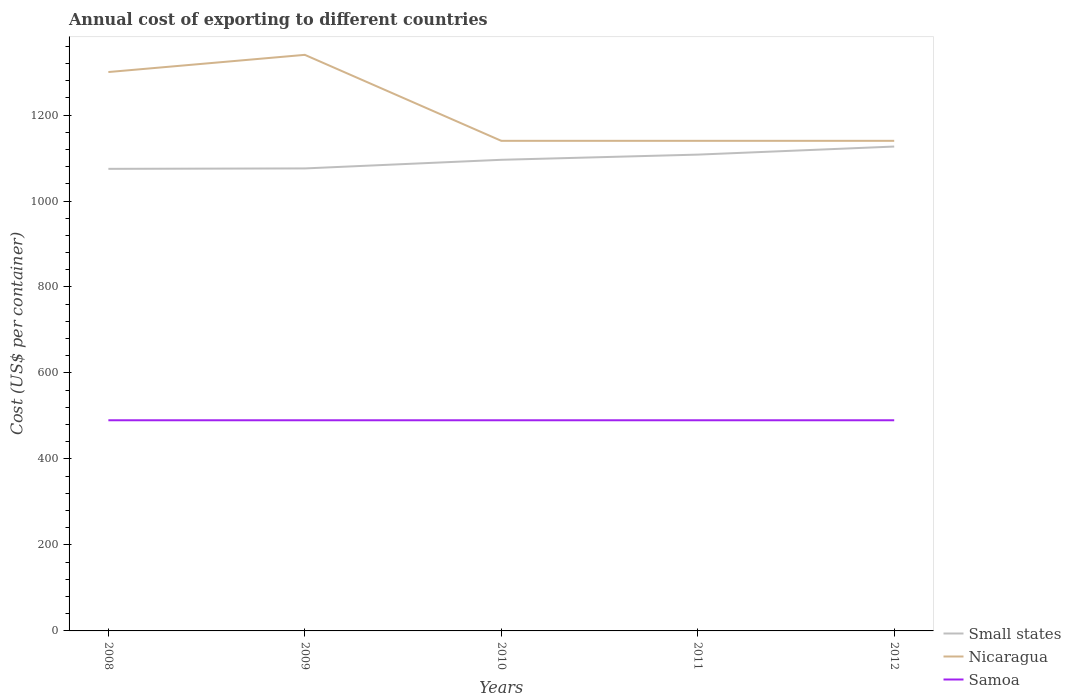Is the number of lines equal to the number of legend labels?
Make the answer very short. Yes. Across all years, what is the maximum total annual cost of exporting in Small states?
Offer a terse response. 1074.82. What is the total total annual cost of exporting in Nicaragua in the graph?
Provide a succinct answer. 200. What is the difference between the highest and the second highest total annual cost of exporting in Nicaragua?
Your answer should be compact. 200. How many lines are there?
Keep it short and to the point. 3. What is the difference between two consecutive major ticks on the Y-axis?
Keep it short and to the point. 200. Does the graph contain any zero values?
Ensure brevity in your answer.  No. What is the title of the graph?
Keep it short and to the point. Annual cost of exporting to different countries. What is the label or title of the Y-axis?
Offer a terse response. Cost (US$ per container). What is the Cost (US$ per container) of Small states in 2008?
Your answer should be compact. 1074.82. What is the Cost (US$ per container) of Nicaragua in 2008?
Offer a terse response. 1300. What is the Cost (US$ per container) in Samoa in 2008?
Ensure brevity in your answer.  490. What is the Cost (US$ per container) in Small states in 2009?
Ensure brevity in your answer.  1075.79. What is the Cost (US$ per container) of Nicaragua in 2009?
Provide a short and direct response. 1340. What is the Cost (US$ per container) of Samoa in 2009?
Your response must be concise. 490. What is the Cost (US$ per container) of Small states in 2010?
Your answer should be compact. 1095.87. What is the Cost (US$ per container) of Nicaragua in 2010?
Provide a succinct answer. 1140. What is the Cost (US$ per container) of Samoa in 2010?
Your answer should be compact. 490. What is the Cost (US$ per container) of Small states in 2011?
Your answer should be compact. 1107.92. What is the Cost (US$ per container) in Nicaragua in 2011?
Make the answer very short. 1140. What is the Cost (US$ per container) in Samoa in 2011?
Offer a very short reply. 490. What is the Cost (US$ per container) of Small states in 2012?
Keep it short and to the point. 1126.7. What is the Cost (US$ per container) in Nicaragua in 2012?
Your answer should be compact. 1140. What is the Cost (US$ per container) in Samoa in 2012?
Make the answer very short. 490. Across all years, what is the maximum Cost (US$ per container) of Small states?
Ensure brevity in your answer.  1126.7. Across all years, what is the maximum Cost (US$ per container) in Nicaragua?
Give a very brief answer. 1340. Across all years, what is the maximum Cost (US$ per container) in Samoa?
Ensure brevity in your answer.  490. Across all years, what is the minimum Cost (US$ per container) of Small states?
Give a very brief answer. 1074.82. Across all years, what is the minimum Cost (US$ per container) of Nicaragua?
Your answer should be compact. 1140. Across all years, what is the minimum Cost (US$ per container) in Samoa?
Ensure brevity in your answer.  490. What is the total Cost (US$ per container) of Small states in the graph?
Make the answer very short. 5481.11. What is the total Cost (US$ per container) in Nicaragua in the graph?
Ensure brevity in your answer.  6060. What is the total Cost (US$ per container) of Samoa in the graph?
Keep it short and to the point. 2450. What is the difference between the Cost (US$ per container) in Small states in 2008 and that in 2009?
Make the answer very short. -0.97. What is the difference between the Cost (US$ per container) in Nicaragua in 2008 and that in 2009?
Give a very brief answer. -40. What is the difference between the Cost (US$ per container) of Small states in 2008 and that in 2010?
Your answer should be compact. -21.05. What is the difference between the Cost (US$ per container) in Nicaragua in 2008 and that in 2010?
Your response must be concise. 160. What is the difference between the Cost (US$ per container) of Small states in 2008 and that in 2011?
Give a very brief answer. -33.1. What is the difference between the Cost (US$ per container) of Nicaragua in 2008 and that in 2011?
Offer a terse response. 160. What is the difference between the Cost (US$ per container) in Small states in 2008 and that in 2012?
Make the answer very short. -51.88. What is the difference between the Cost (US$ per container) of Nicaragua in 2008 and that in 2012?
Ensure brevity in your answer.  160. What is the difference between the Cost (US$ per container) of Small states in 2009 and that in 2010?
Your response must be concise. -20.08. What is the difference between the Cost (US$ per container) in Samoa in 2009 and that in 2010?
Provide a succinct answer. 0. What is the difference between the Cost (US$ per container) of Small states in 2009 and that in 2011?
Give a very brief answer. -32.13. What is the difference between the Cost (US$ per container) in Nicaragua in 2009 and that in 2011?
Keep it short and to the point. 200. What is the difference between the Cost (US$ per container) of Small states in 2009 and that in 2012?
Your response must be concise. -50.91. What is the difference between the Cost (US$ per container) in Nicaragua in 2009 and that in 2012?
Your answer should be compact. 200. What is the difference between the Cost (US$ per container) of Samoa in 2009 and that in 2012?
Offer a very short reply. 0. What is the difference between the Cost (US$ per container) in Small states in 2010 and that in 2011?
Offer a terse response. -12.05. What is the difference between the Cost (US$ per container) in Samoa in 2010 and that in 2011?
Offer a terse response. 0. What is the difference between the Cost (US$ per container) in Small states in 2010 and that in 2012?
Ensure brevity in your answer.  -30.83. What is the difference between the Cost (US$ per container) of Samoa in 2010 and that in 2012?
Your response must be concise. 0. What is the difference between the Cost (US$ per container) of Small states in 2011 and that in 2012?
Offer a very short reply. -18.77. What is the difference between the Cost (US$ per container) of Samoa in 2011 and that in 2012?
Offer a very short reply. 0. What is the difference between the Cost (US$ per container) in Small states in 2008 and the Cost (US$ per container) in Nicaragua in 2009?
Ensure brevity in your answer.  -265.18. What is the difference between the Cost (US$ per container) in Small states in 2008 and the Cost (US$ per container) in Samoa in 2009?
Your answer should be very brief. 584.82. What is the difference between the Cost (US$ per container) in Nicaragua in 2008 and the Cost (US$ per container) in Samoa in 2009?
Provide a succinct answer. 810. What is the difference between the Cost (US$ per container) in Small states in 2008 and the Cost (US$ per container) in Nicaragua in 2010?
Your response must be concise. -65.18. What is the difference between the Cost (US$ per container) in Small states in 2008 and the Cost (US$ per container) in Samoa in 2010?
Your answer should be compact. 584.82. What is the difference between the Cost (US$ per container) of Nicaragua in 2008 and the Cost (US$ per container) of Samoa in 2010?
Your answer should be very brief. 810. What is the difference between the Cost (US$ per container) of Small states in 2008 and the Cost (US$ per container) of Nicaragua in 2011?
Provide a short and direct response. -65.18. What is the difference between the Cost (US$ per container) of Small states in 2008 and the Cost (US$ per container) of Samoa in 2011?
Provide a succinct answer. 584.82. What is the difference between the Cost (US$ per container) of Nicaragua in 2008 and the Cost (US$ per container) of Samoa in 2011?
Keep it short and to the point. 810. What is the difference between the Cost (US$ per container) in Small states in 2008 and the Cost (US$ per container) in Nicaragua in 2012?
Make the answer very short. -65.18. What is the difference between the Cost (US$ per container) of Small states in 2008 and the Cost (US$ per container) of Samoa in 2012?
Ensure brevity in your answer.  584.82. What is the difference between the Cost (US$ per container) in Nicaragua in 2008 and the Cost (US$ per container) in Samoa in 2012?
Make the answer very short. 810. What is the difference between the Cost (US$ per container) in Small states in 2009 and the Cost (US$ per container) in Nicaragua in 2010?
Give a very brief answer. -64.21. What is the difference between the Cost (US$ per container) of Small states in 2009 and the Cost (US$ per container) of Samoa in 2010?
Your response must be concise. 585.79. What is the difference between the Cost (US$ per container) of Nicaragua in 2009 and the Cost (US$ per container) of Samoa in 2010?
Give a very brief answer. 850. What is the difference between the Cost (US$ per container) in Small states in 2009 and the Cost (US$ per container) in Nicaragua in 2011?
Keep it short and to the point. -64.21. What is the difference between the Cost (US$ per container) of Small states in 2009 and the Cost (US$ per container) of Samoa in 2011?
Offer a very short reply. 585.79. What is the difference between the Cost (US$ per container) in Nicaragua in 2009 and the Cost (US$ per container) in Samoa in 2011?
Your answer should be very brief. 850. What is the difference between the Cost (US$ per container) in Small states in 2009 and the Cost (US$ per container) in Nicaragua in 2012?
Ensure brevity in your answer.  -64.21. What is the difference between the Cost (US$ per container) in Small states in 2009 and the Cost (US$ per container) in Samoa in 2012?
Keep it short and to the point. 585.79. What is the difference between the Cost (US$ per container) of Nicaragua in 2009 and the Cost (US$ per container) of Samoa in 2012?
Offer a terse response. 850. What is the difference between the Cost (US$ per container) of Small states in 2010 and the Cost (US$ per container) of Nicaragua in 2011?
Your answer should be compact. -44.13. What is the difference between the Cost (US$ per container) in Small states in 2010 and the Cost (US$ per container) in Samoa in 2011?
Provide a short and direct response. 605.87. What is the difference between the Cost (US$ per container) in Nicaragua in 2010 and the Cost (US$ per container) in Samoa in 2011?
Make the answer very short. 650. What is the difference between the Cost (US$ per container) in Small states in 2010 and the Cost (US$ per container) in Nicaragua in 2012?
Give a very brief answer. -44.13. What is the difference between the Cost (US$ per container) of Small states in 2010 and the Cost (US$ per container) of Samoa in 2012?
Your answer should be very brief. 605.87. What is the difference between the Cost (US$ per container) in Nicaragua in 2010 and the Cost (US$ per container) in Samoa in 2012?
Give a very brief answer. 650. What is the difference between the Cost (US$ per container) of Small states in 2011 and the Cost (US$ per container) of Nicaragua in 2012?
Give a very brief answer. -32.08. What is the difference between the Cost (US$ per container) of Small states in 2011 and the Cost (US$ per container) of Samoa in 2012?
Give a very brief answer. 617.92. What is the difference between the Cost (US$ per container) of Nicaragua in 2011 and the Cost (US$ per container) of Samoa in 2012?
Keep it short and to the point. 650. What is the average Cost (US$ per container) of Small states per year?
Provide a succinct answer. 1096.22. What is the average Cost (US$ per container) in Nicaragua per year?
Provide a short and direct response. 1212. What is the average Cost (US$ per container) of Samoa per year?
Offer a very short reply. 490. In the year 2008, what is the difference between the Cost (US$ per container) in Small states and Cost (US$ per container) in Nicaragua?
Keep it short and to the point. -225.18. In the year 2008, what is the difference between the Cost (US$ per container) of Small states and Cost (US$ per container) of Samoa?
Offer a very short reply. 584.82. In the year 2008, what is the difference between the Cost (US$ per container) in Nicaragua and Cost (US$ per container) in Samoa?
Your answer should be compact. 810. In the year 2009, what is the difference between the Cost (US$ per container) of Small states and Cost (US$ per container) of Nicaragua?
Provide a succinct answer. -264.21. In the year 2009, what is the difference between the Cost (US$ per container) in Small states and Cost (US$ per container) in Samoa?
Offer a very short reply. 585.79. In the year 2009, what is the difference between the Cost (US$ per container) in Nicaragua and Cost (US$ per container) in Samoa?
Make the answer very short. 850. In the year 2010, what is the difference between the Cost (US$ per container) of Small states and Cost (US$ per container) of Nicaragua?
Your answer should be very brief. -44.13. In the year 2010, what is the difference between the Cost (US$ per container) in Small states and Cost (US$ per container) in Samoa?
Give a very brief answer. 605.87. In the year 2010, what is the difference between the Cost (US$ per container) in Nicaragua and Cost (US$ per container) in Samoa?
Keep it short and to the point. 650. In the year 2011, what is the difference between the Cost (US$ per container) of Small states and Cost (US$ per container) of Nicaragua?
Provide a succinct answer. -32.08. In the year 2011, what is the difference between the Cost (US$ per container) in Small states and Cost (US$ per container) in Samoa?
Your answer should be compact. 617.92. In the year 2011, what is the difference between the Cost (US$ per container) of Nicaragua and Cost (US$ per container) of Samoa?
Your response must be concise. 650. In the year 2012, what is the difference between the Cost (US$ per container) in Small states and Cost (US$ per container) in Nicaragua?
Make the answer very short. -13.3. In the year 2012, what is the difference between the Cost (US$ per container) of Small states and Cost (US$ per container) of Samoa?
Your answer should be compact. 636.7. In the year 2012, what is the difference between the Cost (US$ per container) of Nicaragua and Cost (US$ per container) of Samoa?
Your answer should be compact. 650. What is the ratio of the Cost (US$ per container) in Nicaragua in 2008 to that in 2009?
Make the answer very short. 0.97. What is the ratio of the Cost (US$ per container) of Samoa in 2008 to that in 2009?
Keep it short and to the point. 1. What is the ratio of the Cost (US$ per container) of Small states in 2008 to that in 2010?
Your answer should be very brief. 0.98. What is the ratio of the Cost (US$ per container) in Nicaragua in 2008 to that in 2010?
Ensure brevity in your answer.  1.14. What is the ratio of the Cost (US$ per container) of Small states in 2008 to that in 2011?
Give a very brief answer. 0.97. What is the ratio of the Cost (US$ per container) of Nicaragua in 2008 to that in 2011?
Ensure brevity in your answer.  1.14. What is the ratio of the Cost (US$ per container) in Samoa in 2008 to that in 2011?
Give a very brief answer. 1. What is the ratio of the Cost (US$ per container) in Small states in 2008 to that in 2012?
Provide a succinct answer. 0.95. What is the ratio of the Cost (US$ per container) of Nicaragua in 2008 to that in 2012?
Your answer should be compact. 1.14. What is the ratio of the Cost (US$ per container) of Samoa in 2008 to that in 2012?
Give a very brief answer. 1. What is the ratio of the Cost (US$ per container) of Small states in 2009 to that in 2010?
Your answer should be very brief. 0.98. What is the ratio of the Cost (US$ per container) in Nicaragua in 2009 to that in 2010?
Your answer should be compact. 1.18. What is the ratio of the Cost (US$ per container) of Nicaragua in 2009 to that in 2011?
Provide a succinct answer. 1.18. What is the ratio of the Cost (US$ per container) in Small states in 2009 to that in 2012?
Keep it short and to the point. 0.95. What is the ratio of the Cost (US$ per container) in Nicaragua in 2009 to that in 2012?
Offer a terse response. 1.18. What is the ratio of the Cost (US$ per container) in Nicaragua in 2010 to that in 2011?
Keep it short and to the point. 1. What is the ratio of the Cost (US$ per container) in Samoa in 2010 to that in 2011?
Keep it short and to the point. 1. What is the ratio of the Cost (US$ per container) in Small states in 2010 to that in 2012?
Ensure brevity in your answer.  0.97. What is the ratio of the Cost (US$ per container) of Nicaragua in 2010 to that in 2012?
Your answer should be very brief. 1. What is the ratio of the Cost (US$ per container) in Small states in 2011 to that in 2012?
Your response must be concise. 0.98. What is the difference between the highest and the second highest Cost (US$ per container) of Small states?
Provide a short and direct response. 18.77. What is the difference between the highest and the second highest Cost (US$ per container) in Nicaragua?
Make the answer very short. 40. What is the difference between the highest and the lowest Cost (US$ per container) in Small states?
Offer a very short reply. 51.88. What is the difference between the highest and the lowest Cost (US$ per container) in Nicaragua?
Provide a succinct answer. 200. 